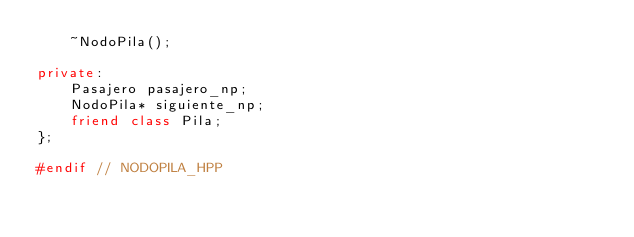Convert code to text. <code><loc_0><loc_0><loc_500><loc_500><_C++_>    ~NodoPila();
    
private:
    Pasajero pasajero_np;
    NodoPila* siguiente_np;
    friend class Pila;
};

#endif // NODOPILA_HPP</code> 